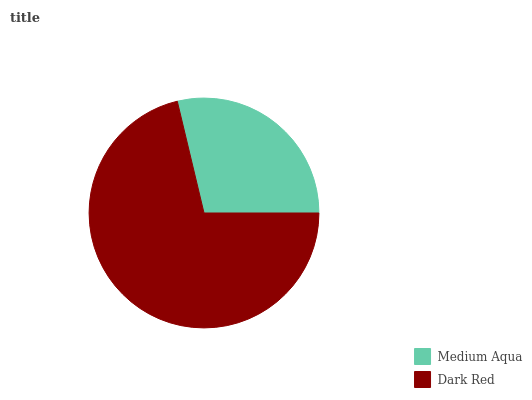Is Medium Aqua the minimum?
Answer yes or no. Yes. Is Dark Red the maximum?
Answer yes or no. Yes. Is Dark Red the minimum?
Answer yes or no. No. Is Dark Red greater than Medium Aqua?
Answer yes or no. Yes. Is Medium Aqua less than Dark Red?
Answer yes or no. Yes. Is Medium Aqua greater than Dark Red?
Answer yes or no. No. Is Dark Red less than Medium Aqua?
Answer yes or no. No. Is Dark Red the high median?
Answer yes or no. Yes. Is Medium Aqua the low median?
Answer yes or no. Yes. Is Medium Aqua the high median?
Answer yes or no. No. Is Dark Red the low median?
Answer yes or no. No. 